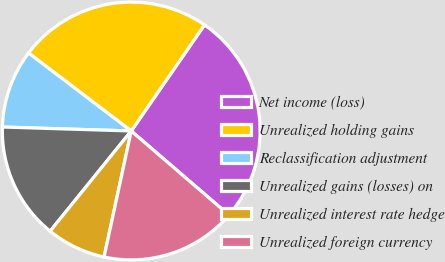Convert chart. <chart><loc_0><loc_0><loc_500><loc_500><pie_chart><fcel>Net income (loss)<fcel>Unrealized holding gains<fcel>Reclassification adjustment<fcel>Unrealized gains (losses) on<fcel>Unrealized interest rate hedge<fcel>Unrealized foreign currency<nl><fcel>26.69%<fcel>24.28%<fcel>9.85%<fcel>14.66%<fcel>7.45%<fcel>17.07%<nl></chart> 